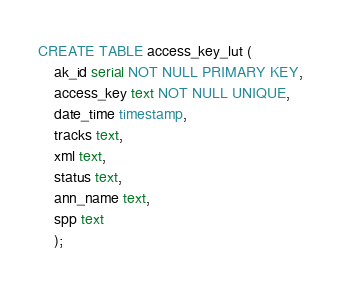Convert code to text. <code><loc_0><loc_0><loc_500><loc_500><_SQL_>CREATE TABLE access_key_lut (
	ak_id serial NOT NULL PRIMARY KEY,
	access_key text NOT NULL UNIQUE,
	date_time timestamp,
	tracks text,
	xml text,
	status text,
	ann_name text,
	spp text
	);</code> 